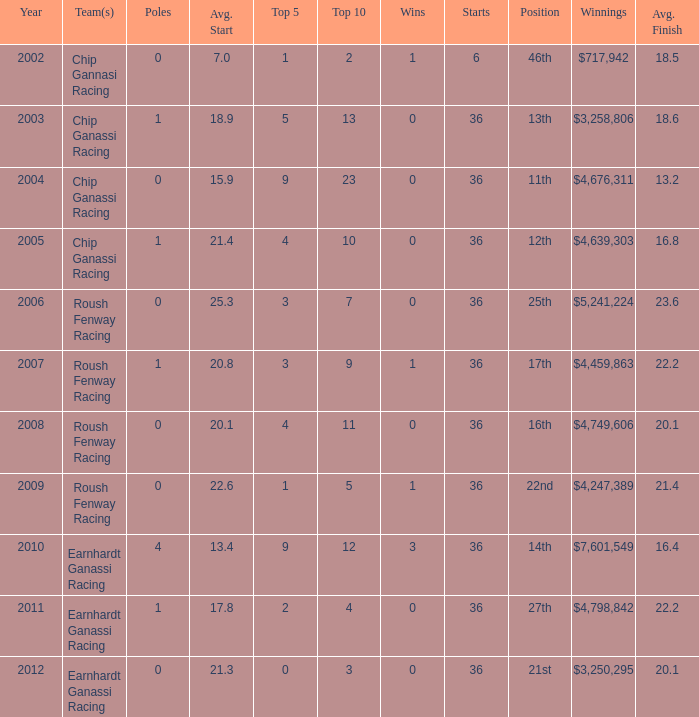Name the starts when position is 16th 36.0. 